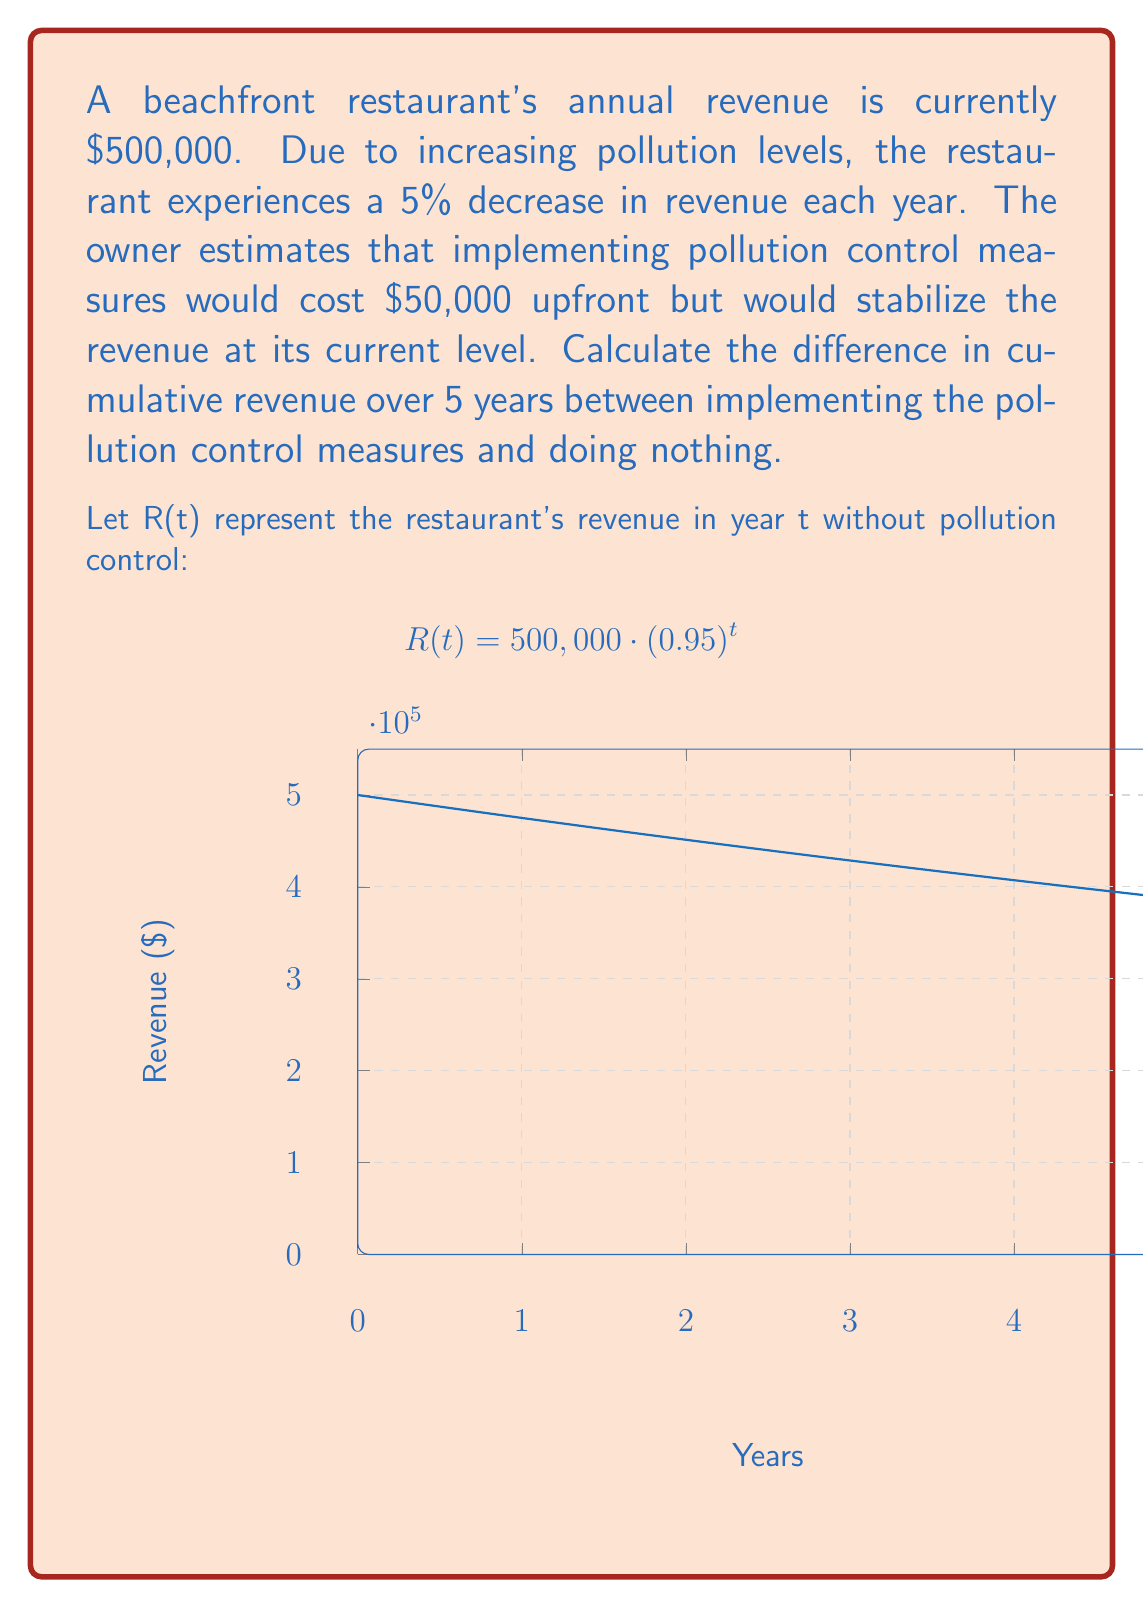Can you solve this math problem? Let's approach this step-by-step:

1. Calculate the cumulative revenue over 5 years with pollution control:
   - Annual revenue remains constant at $500,000
   - Cumulative revenue = $500,000 × 5 - $50,000 (upfront cost)
   - Cumulative revenue with control = $2,450,000

2. Calculate the cumulative revenue over 5 years without pollution control:
   - Use the formula $R(t) = 500,000 \cdot (0.95)^t$ for each year
   - Year 1: $500,000 \cdot (0.95)^1 = $475,000
   - Year 2: $500,000 \cdot (0.95)^2 = $451,250
   - Year 3: $500,000 \cdot (0.95)^3 = $428,687.50
   - Year 4: $500,000 \cdot (0.95)^4 = $407,253.13
   - Year 5: $500,000 \cdot (0.95)^5 = $386,890.47

3. Sum the revenues for all 5 years without pollution control:
   $500,000 + $475,000 + $451,250 + $428,687.50 + $407,253.13 + $386,890.47 = $2,149,081.10

4. Calculate the difference:
   Difference = Revenue with control - Revenue without control
   $2,450,000 - $2,149,081.10 = $300,918.90
Answer: $300,918.90 